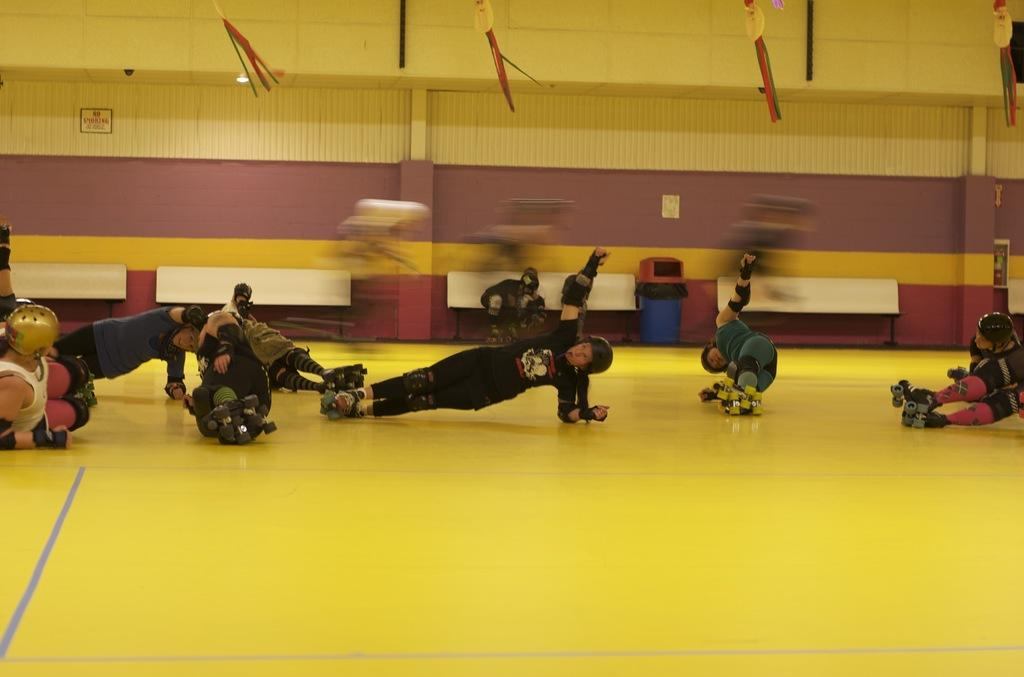How many people are in the image? There are many people in the image. What protective gear are the people wearing? The people are wearing helmets, elbow pads, knee pads, and skating shoes. What can be seen in the background of the image? There is a wall in the background of the image. What object is near the wall? There is a bin near the wall. What time of day is it in the image, and what is the condition of the sidewalk? The provided facts do not mention the time of day or the presence of a sidewalk in the image. 